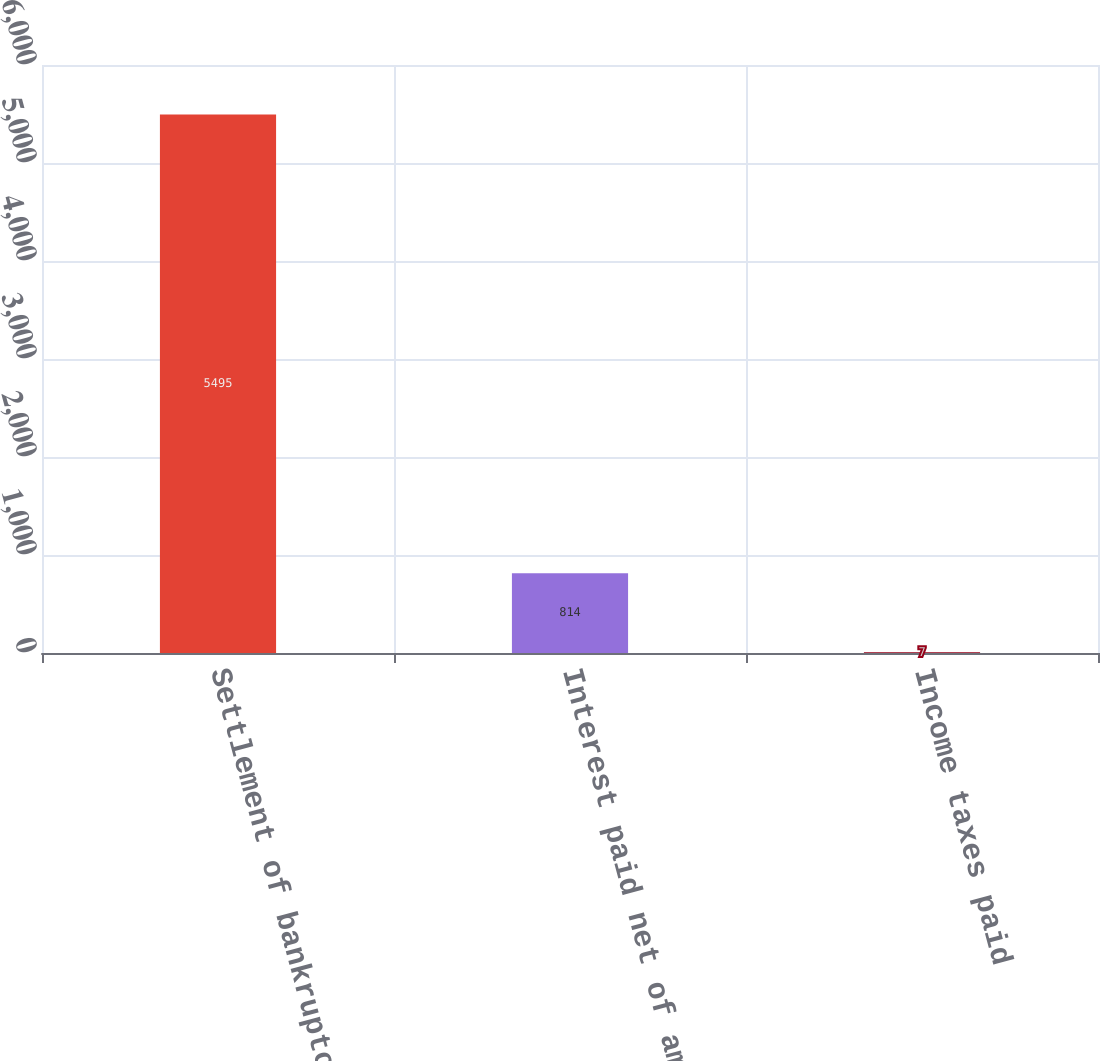Convert chart to OTSL. <chart><loc_0><loc_0><loc_500><loc_500><bar_chart><fcel>Settlement of bankruptcy<fcel>Interest paid net of amounts<fcel>Income taxes paid<nl><fcel>5495<fcel>814<fcel>7<nl></chart> 